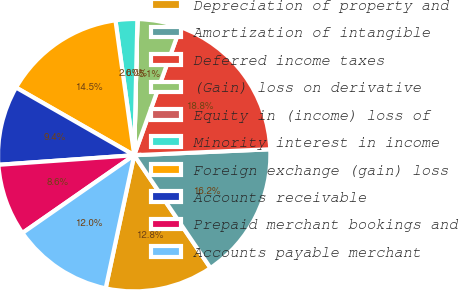Convert chart to OTSL. <chart><loc_0><loc_0><loc_500><loc_500><pie_chart><fcel>Depreciation of property and<fcel>Amortization of intangible<fcel>Deferred income taxes<fcel>(Gain) loss on derivative<fcel>Equity in (income) loss of<fcel>Minority interest in income<fcel>Foreign exchange (gain) loss<fcel>Accounts receivable<fcel>Prepaid merchant bookings and<fcel>Accounts payable merchant<nl><fcel>12.82%<fcel>16.23%<fcel>18.79%<fcel>5.13%<fcel>0.01%<fcel>2.57%<fcel>14.52%<fcel>9.4%<fcel>8.55%<fcel>11.96%<nl></chart> 